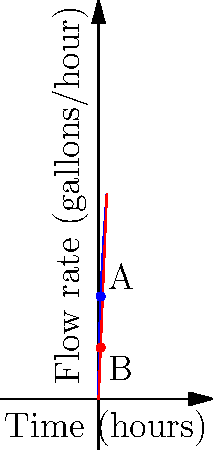As a plumber, you're monitoring the water flow rate through a pipe. The blue curve represents the actual flow rate $f(t) = 50\sqrt{t}$ gallons per hour, where $t$ is the time in hours. At $t=1$ hour, you want to use a linear approximation (red line) to estimate the flow rate for the next few minutes. What is the slope of this linear approximation? Let's approach this step-by-step:

1) The linear approximation is the tangent line to the curve at $t=1$. Its slope is the derivative of $f(t)$ at $t=1$.

2) To find the derivative, we use the power rule:
   $f(t) = 50\sqrt{t} = 50t^{1/2}$
   $f'(t) = 50 \cdot \frac{1}{2}t^{-1/2} = \frac{25}{\sqrt{t}}$

3) Now, we evaluate $f'(t)$ at $t=1$:
   $f'(1) = \frac{25}{\sqrt{1}} = 25$

4) This means that at $t=1$, the rate of change of the flow rate is 25 gallons per hour per hour.

5) In plumbing terms, this indicates that for each additional hour (near $t=1$), the flow rate increases by approximately 25 gallons per hour.

6) The slope of the linear approximation (red line) is this derivative value, 25.
Answer: 25 gallons per hour per hour 